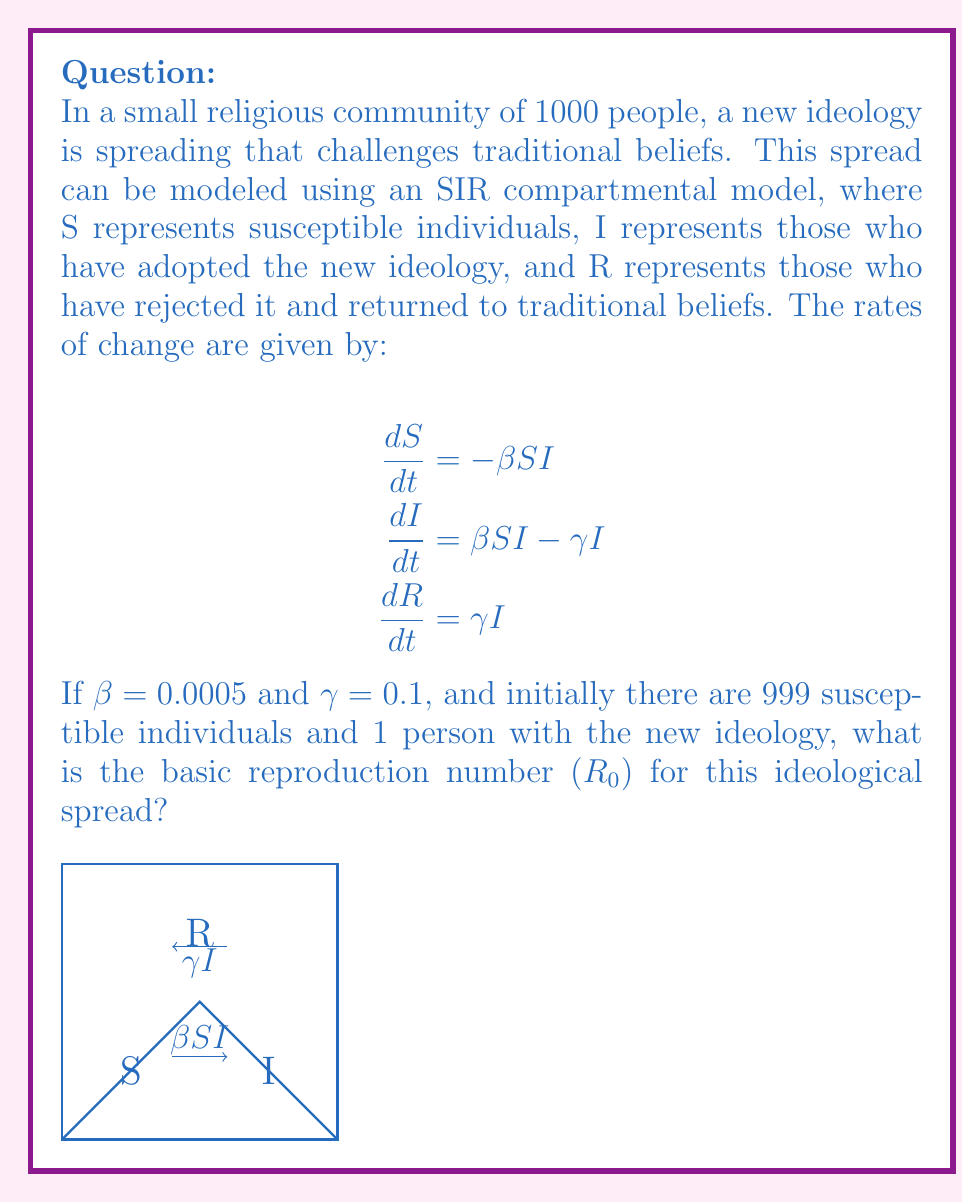Can you answer this question? To solve this problem, we need to understand the concept of the basic reproduction number ($R_0$) in the context of an SIR model:

1) The basic reproduction number ($R_0$) represents the average number of secondary cases one infected individual will cause during their infectious period in a completely susceptible population.

2) In an SIR model, $R_0$ is calculated as the ratio of the infection rate ($\beta$) to the recovery rate ($\gamma$), multiplied by the initial susceptible population ($S_0$):

   $$R_0 = \frac{\beta S_0}{\gamma}$$

3) We are given:
   - $\beta = 0.0005$ (infection rate)
   - $\gamma = 0.1$ (recovery rate)
   - Initial susceptible population $S_0 = 999$

4) Substituting these values into the formula:

   $$R_0 = \frac{0.0005 \times 999}{0.1}$$

5) Simplifying:
   $$R_0 = \frac{0.4995}{0.1} = 4.995$$

Therefore, the basic reproduction number for this ideological spread is approximately 4.995.
Answer: $R_0 \approx 4.995$ 